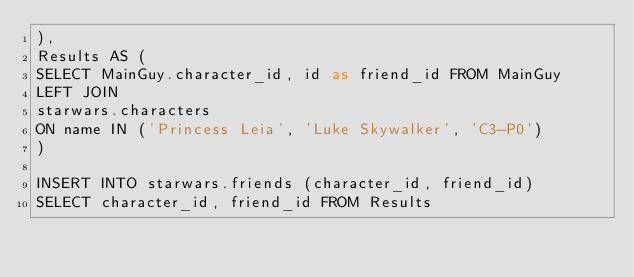<code> <loc_0><loc_0><loc_500><loc_500><_SQL_>), 
Results AS (
SELECT MainGuy.character_id, id as friend_id FROM MainGuy
LEFT JOIN
starwars.characters 
ON name IN ('Princess Leia', 'Luke Skywalker', 'C3-P0')
)

INSERT INTO starwars.friends (character_id, friend_id)
SELECT character_id, friend_id FROM Results

</code> 